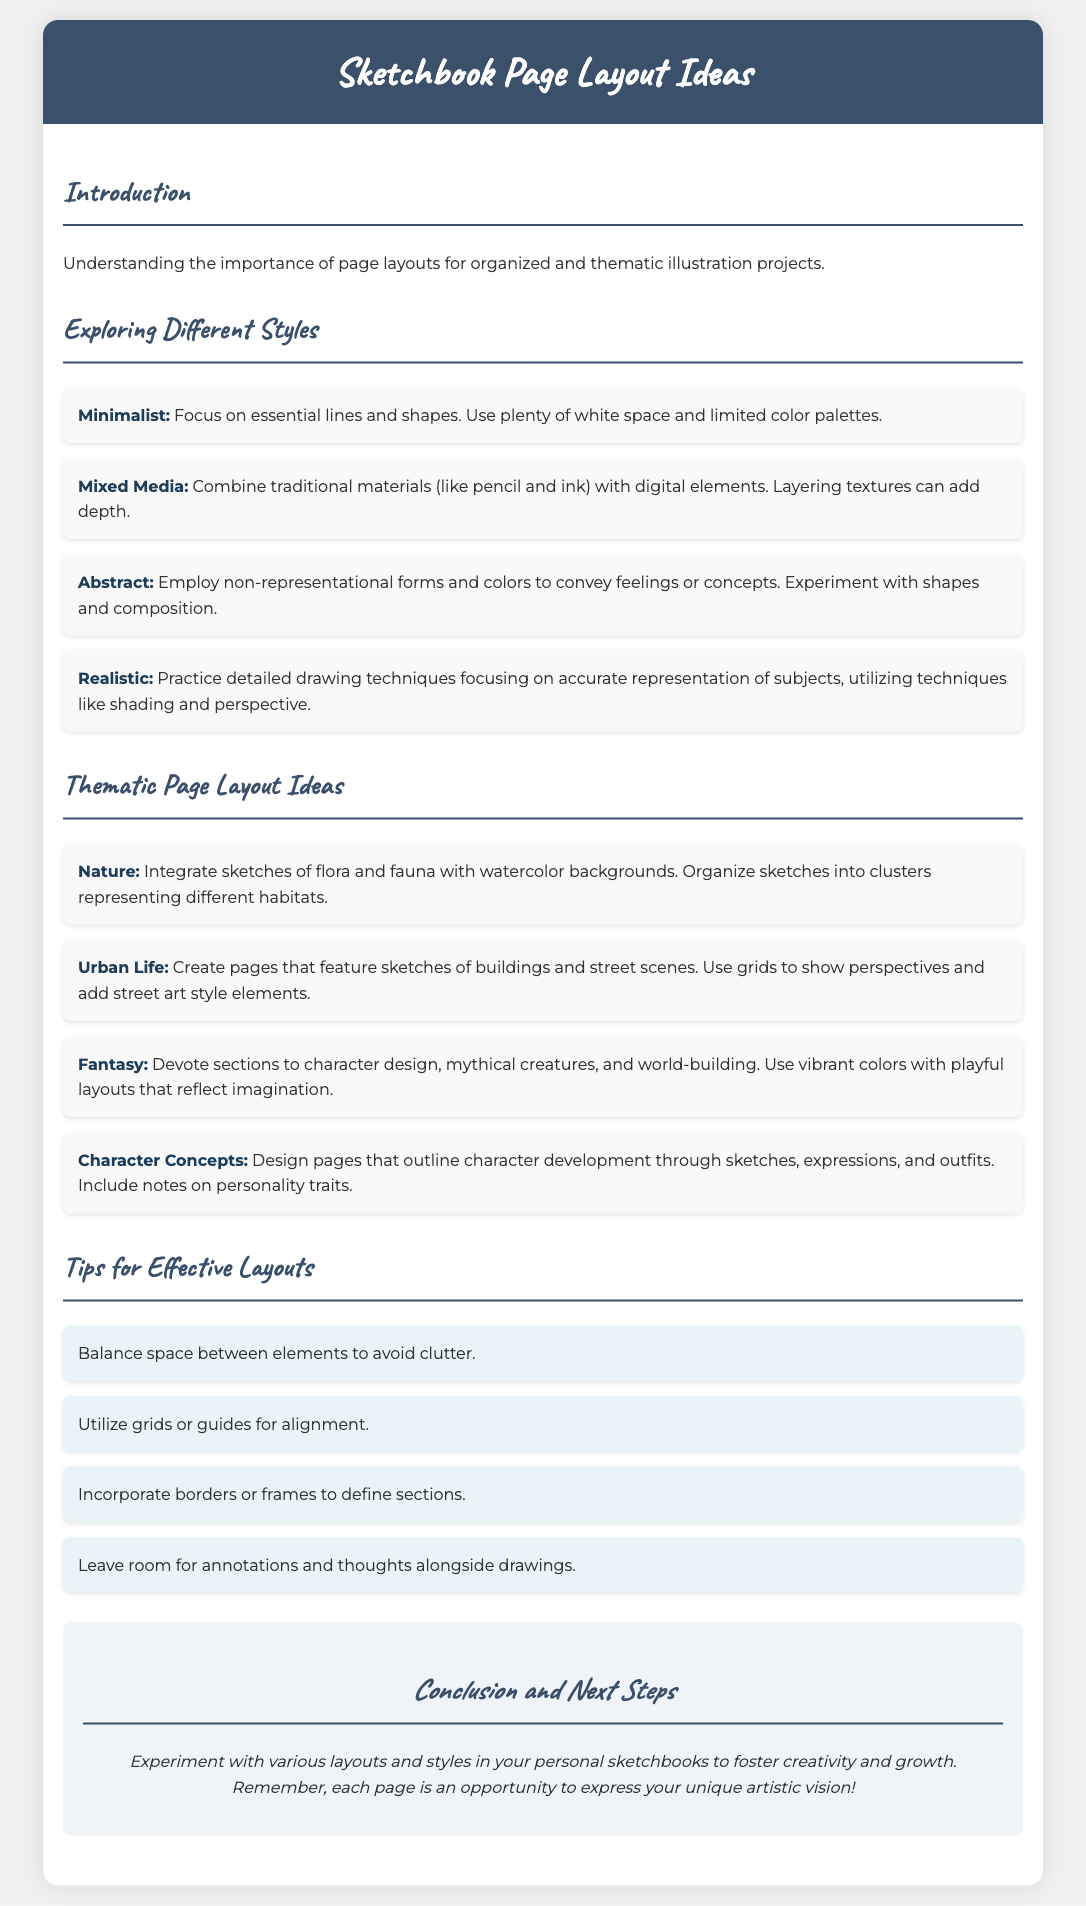What is the title of the document? The title is indicated in the header of the document.
Answer: Sketchbook Page Layout Ideas What is one style mentioned under "Exploring Different Styles"? The document lists several styles, and one can be identified from the list.
Answer: Minimalist What color scheme is suggested for the "Nature" theme? The suggested theme integrates sketches with a particular type of background.
Answer: Watercolor backgrounds How many thematic layout ideas are provided in the document? A count of the thematic ideas can be determined from the list provided.
Answer: Four What is one tip for effective layouts mentioned? The document includes a section with specific tips for layout effectiveness.
Answer: Balance space between elements What type of sketches are included in the "Urban Life" theme? The theme describes the nature of sketches featured on the pages.
Answer: Buildings and street scenes What is the color suggestion for the "Fantasy" theme? The document describes an aesthetic aspect for this theme.
Answer: Vibrant colors What is the primary purpose of the "Introduction" section? The introduction sets the tone for the content that follows.
Answer: Understanding the importance of page layouts 